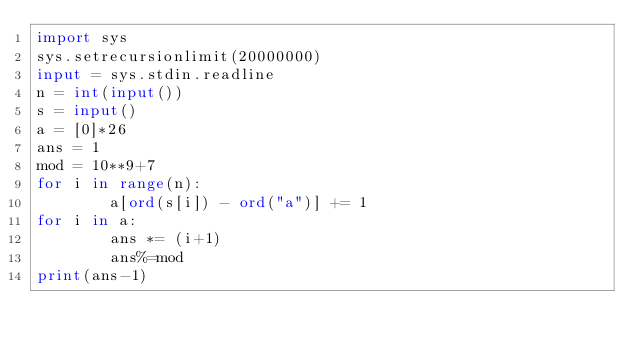Convert code to text. <code><loc_0><loc_0><loc_500><loc_500><_Python_>import sys
sys.setrecursionlimit(20000000)
input = sys.stdin.readline
n = int(input())
s = input()
a = [0]*26
ans = 1
mod = 10**9+7
for i in range(n):
        a[ord(s[i]) - ord("a")] += 1
for i in a:
        ans *= (i+1)
        ans%=mod
print(ans-1)</code> 